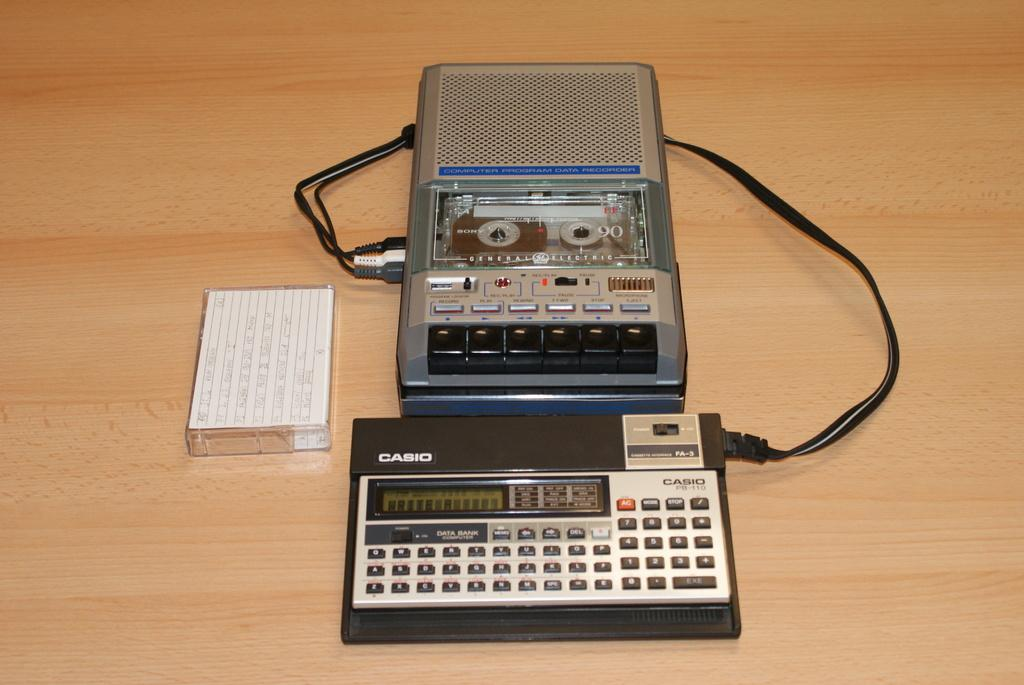<image>
Relay a brief, clear account of the picture shown. A Casio calculator that is connected to a tape recorder. 